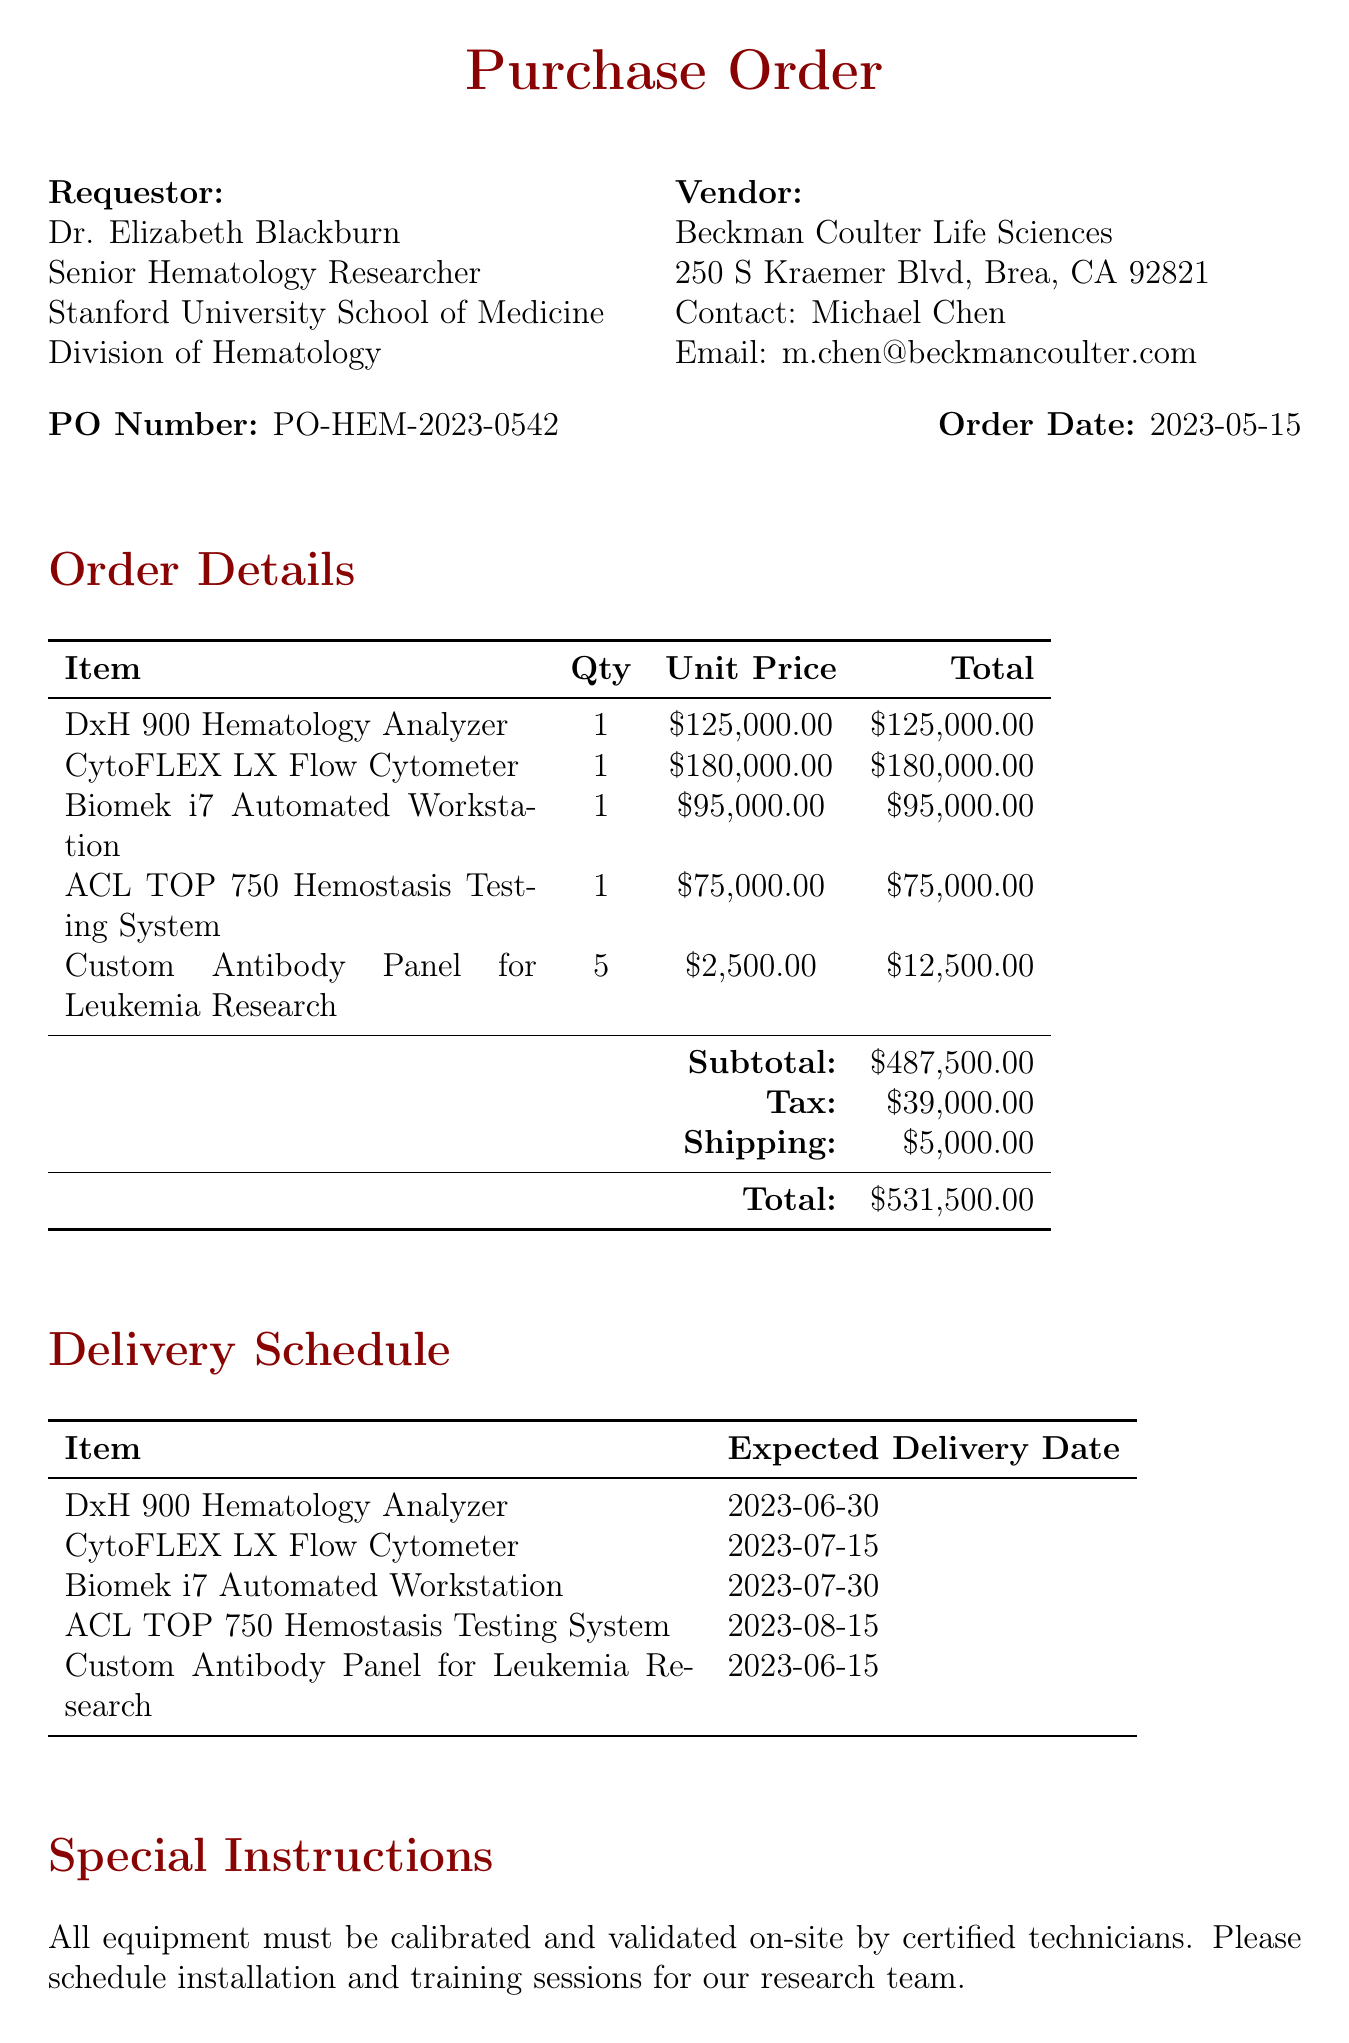What is the purchase order number? The purchase order number is specified at the beginning of the document, labeled as PO Number.
Answer: PO-HEM-2023-0542 Who is the requestor of the purchase order? The requestor's details are included in the document, listing "Dr. Elizabeth Blackburn" as the Senior Hematology Researcher.
Answer: Dr. Elizabeth Blackburn What is the total cost of the purchase order? The total cost is presented at the end of the itemized costs, reflecting all charges including tax and shipping.
Answer: $531,500.00 When is the expected delivery date for the CytoFLEX LX Flow Cytometer? The expected delivery date for this item is included in the delivery schedule section.
Answer: 2023-07-15 What is the subtotal amount before tax and shipping? The subtotal amount is indicated prior to the additions of tax and shipping in the order details section of the document.
Answer: $487,500.00 What is the special instruction regarding equipment installation? The document specifies particular requirements for installation and validation, which are listed under special instructions.
Answer: All equipment must be calibrated and validated on-site by certified technicians Who is the principal investigator for the research project? The principal investigator is mentioned in the research project details section of the document.
Answer: Dr. Elizabeth Blackburn What is the expected delivery date for the Custom Antibody Panel for Leukemia Research? This date is provided in the delivery schedule section of the document.
Answer: 2023-06-15 